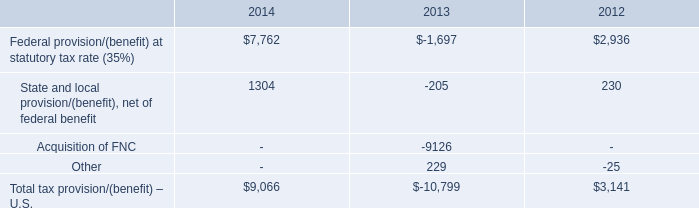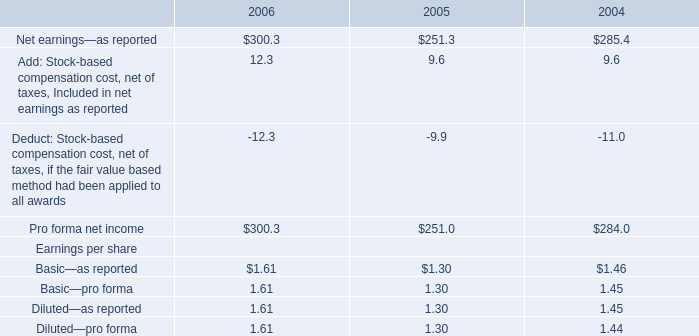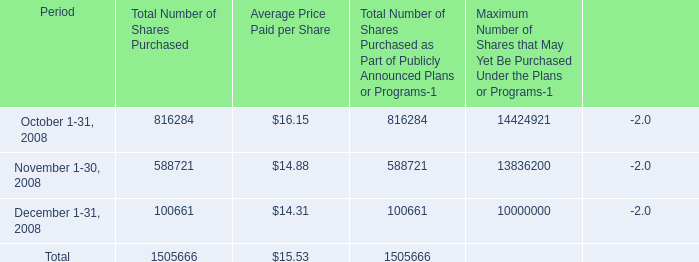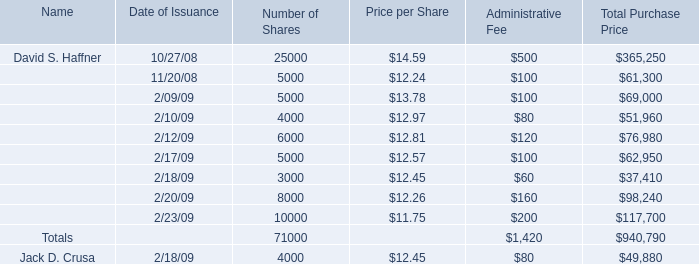What was the total amount of Price per Share greater than 13 for Price per Share? 
Computations: (14.59 + 13.78)
Answer: 28.37. 